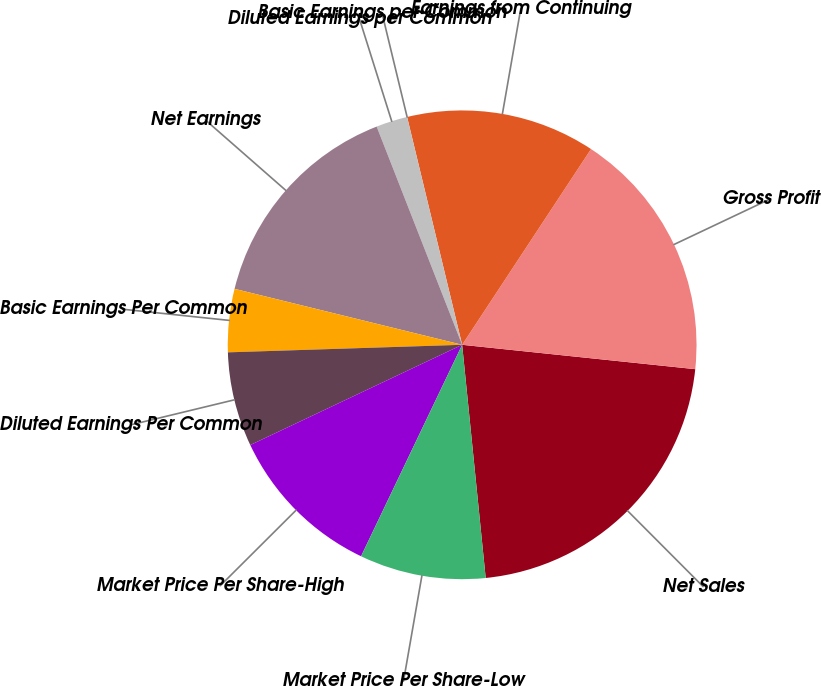<chart> <loc_0><loc_0><loc_500><loc_500><pie_chart><fcel>Net Sales<fcel>Gross Profit<fcel>Earnings from Continuing<fcel>Basic Earnings per Common<fcel>Diluted Earnings per Common<fcel>Net Earnings<fcel>Basic Earnings Per Common<fcel>Diluted Earnings Per Common<fcel>Market Price Per Share-High<fcel>Market Price Per Share-Low<nl><fcel>21.74%<fcel>17.39%<fcel>13.04%<fcel>0.0%<fcel>2.17%<fcel>15.22%<fcel>4.35%<fcel>6.52%<fcel>10.87%<fcel>8.7%<nl></chart> 